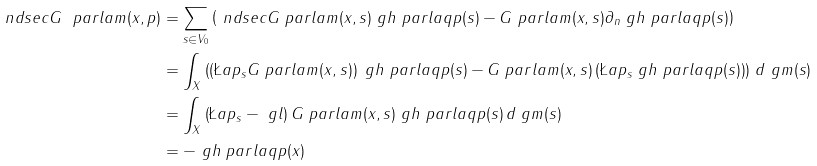Convert formula to latex. <formula><loc_0><loc_0><loc_500><loc_500>\ n d s e c G \ p a r l a m ( x , p ) & = \sum _ { s \in V _ { 0 } } \left ( \ n d s e c G \ p a r l a m ( x , s ) \ g h \ p a r l a q { p } ( s ) - G \ p a r l a m ( x , s ) \partial _ { n } \ g h \ p a r l a q { p } ( s ) \right ) \\ & = \int _ { X } \left ( \left ( \L a p _ { s } G \ p a r l a m ( x , s ) \right ) \ g h \ p a r l a q { p } ( s ) - G \ p a r l a m ( x , s ) \left ( \L a p _ { s } \ g h \ p a r l a q { p } ( s ) \right ) \right ) \, d \ g m ( s ) \\ & = \int _ { X } \left ( \L a p _ { s } - \ g l \right ) G \ p a r l a m ( x , s ) \ g h \ p a r l a q { p } ( s ) \, d \ g m ( s ) \\ & = - \ g h \ p a r l a q { p } ( x )</formula> 